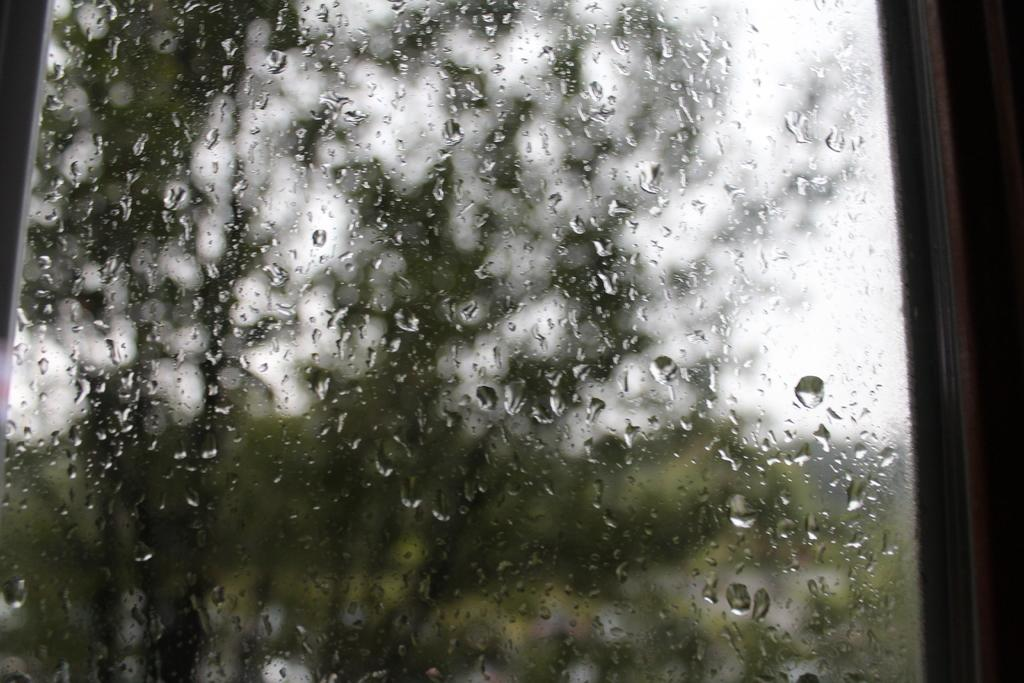What is in the glass that is visible in the image? There is a glass with water drops in the image. What does the glass provide a view of? The glass provides a view of the outside. What type of vegetation can be seen through the glass? Trees are visible through the glass. What else can be seen through the glass besides the trees? The sky is visible through the glass. What type of cream can be seen floating on the water in the glass? There is no cream present in the image; the glass contains water drops. 